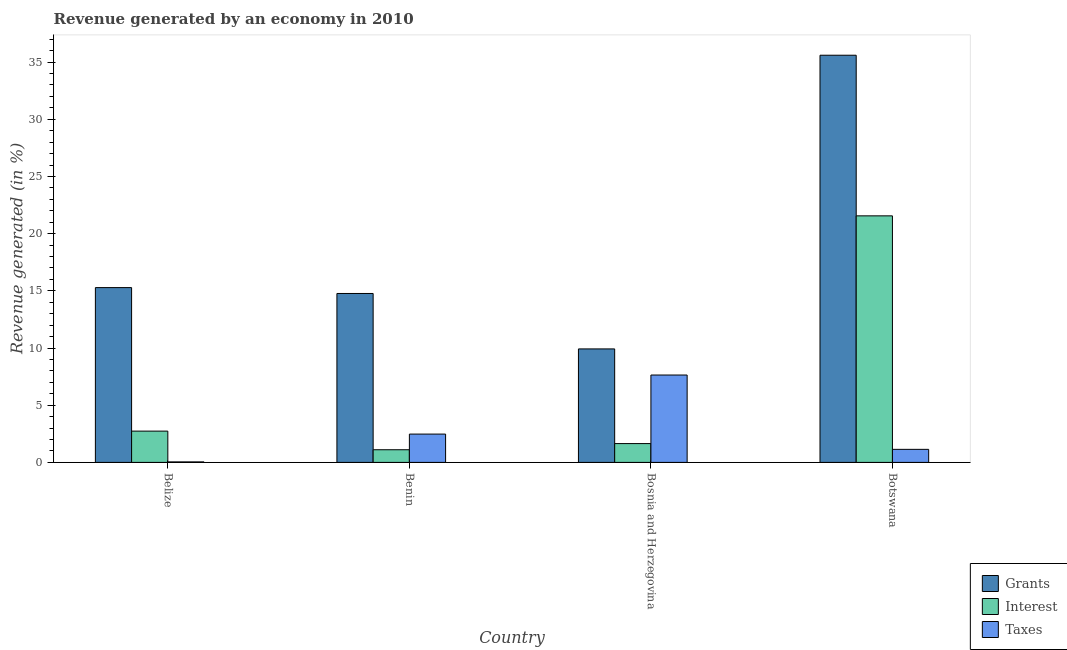Are the number of bars on each tick of the X-axis equal?
Make the answer very short. Yes. What is the label of the 2nd group of bars from the left?
Your answer should be compact. Benin. What is the percentage of revenue generated by interest in Bosnia and Herzegovina?
Keep it short and to the point. 1.64. Across all countries, what is the maximum percentage of revenue generated by taxes?
Ensure brevity in your answer.  7.64. Across all countries, what is the minimum percentage of revenue generated by taxes?
Give a very brief answer. 0.04. In which country was the percentage of revenue generated by interest maximum?
Provide a succinct answer. Botswana. In which country was the percentage of revenue generated by interest minimum?
Your answer should be compact. Benin. What is the total percentage of revenue generated by taxes in the graph?
Keep it short and to the point. 11.3. What is the difference between the percentage of revenue generated by grants in Benin and that in Botswana?
Your answer should be compact. -20.83. What is the difference between the percentage of revenue generated by grants in Benin and the percentage of revenue generated by taxes in Belize?
Make the answer very short. 14.73. What is the average percentage of revenue generated by interest per country?
Keep it short and to the point. 6.76. What is the difference between the percentage of revenue generated by taxes and percentage of revenue generated by interest in Botswana?
Give a very brief answer. -20.42. What is the ratio of the percentage of revenue generated by grants in Benin to that in Botswana?
Offer a very short reply. 0.41. What is the difference between the highest and the second highest percentage of revenue generated by interest?
Your answer should be compact. 18.82. What is the difference between the highest and the lowest percentage of revenue generated by interest?
Your answer should be compact. 20.45. In how many countries, is the percentage of revenue generated by grants greater than the average percentage of revenue generated by grants taken over all countries?
Ensure brevity in your answer.  1. What does the 2nd bar from the left in Belize represents?
Keep it short and to the point. Interest. What does the 3rd bar from the right in Bosnia and Herzegovina represents?
Provide a short and direct response. Grants. What is the difference between two consecutive major ticks on the Y-axis?
Provide a short and direct response. 5. Does the graph contain any zero values?
Give a very brief answer. No. Does the graph contain grids?
Keep it short and to the point. No. How many legend labels are there?
Your answer should be very brief. 3. What is the title of the graph?
Your response must be concise. Revenue generated by an economy in 2010. Does "Male employers" appear as one of the legend labels in the graph?
Provide a short and direct response. No. What is the label or title of the X-axis?
Your answer should be very brief. Country. What is the label or title of the Y-axis?
Ensure brevity in your answer.  Revenue generated (in %). What is the Revenue generated (in %) of Grants in Belize?
Make the answer very short. 15.28. What is the Revenue generated (in %) of Interest in Belize?
Ensure brevity in your answer.  2.74. What is the Revenue generated (in %) of Taxes in Belize?
Your answer should be compact. 0.04. What is the Revenue generated (in %) in Grants in Benin?
Your response must be concise. 14.77. What is the Revenue generated (in %) of Interest in Benin?
Provide a short and direct response. 1.11. What is the Revenue generated (in %) in Taxes in Benin?
Provide a succinct answer. 2.47. What is the Revenue generated (in %) in Grants in Bosnia and Herzegovina?
Your answer should be very brief. 9.92. What is the Revenue generated (in %) in Interest in Bosnia and Herzegovina?
Offer a terse response. 1.64. What is the Revenue generated (in %) of Taxes in Bosnia and Herzegovina?
Offer a very short reply. 7.64. What is the Revenue generated (in %) in Grants in Botswana?
Provide a short and direct response. 35.6. What is the Revenue generated (in %) in Interest in Botswana?
Offer a terse response. 21.56. What is the Revenue generated (in %) in Taxes in Botswana?
Offer a terse response. 1.14. Across all countries, what is the maximum Revenue generated (in %) of Grants?
Your answer should be compact. 35.6. Across all countries, what is the maximum Revenue generated (in %) of Interest?
Offer a terse response. 21.56. Across all countries, what is the maximum Revenue generated (in %) of Taxes?
Ensure brevity in your answer.  7.64. Across all countries, what is the minimum Revenue generated (in %) in Grants?
Your answer should be very brief. 9.92. Across all countries, what is the minimum Revenue generated (in %) of Interest?
Your response must be concise. 1.11. Across all countries, what is the minimum Revenue generated (in %) in Taxes?
Offer a terse response. 0.04. What is the total Revenue generated (in %) of Grants in the graph?
Make the answer very short. 75.57. What is the total Revenue generated (in %) of Interest in the graph?
Offer a terse response. 27.04. What is the total Revenue generated (in %) of Taxes in the graph?
Offer a terse response. 11.3. What is the difference between the Revenue generated (in %) of Grants in Belize and that in Benin?
Keep it short and to the point. 0.51. What is the difference between the Revenue generated (in %) in Interest in Belize and that in Benin?
Provide a succinct answer. 1.63. What is the difference between the Revenue generated (in %) in Taxes in Belize and that in Benin?
Your response must be concise. -2.43. What is the difference between the Revenue generated (in %) of Grants in Belize and that in Bosnia and Herzegovina?
Give a very brief answer. 5.36. What is the difference between the Revenue generated (in %) in Taxes in Belize and that in Bosnia and Herzegovina?
Offer a terse response. -7.6. What is the difference between the Revenue generated (in %) in Grants in Belize and that in Botswana?
Offer a very short reply. -20.32. What is the difference between the Revenue generated (in %) of Interest in Belize and that in Botswana?
Keep it short and to the point. -18.82. What is the difference between the Revenue generated (in %) in Taxes in Belize and that in Botswana?
Keep it short and to the point. -1.1. What is the difference between the Revenue generated (in %) of Grants in Benin and that in Bosnia and Herzegovina?
Ensure brevity in your answer.  4.85. What is the difference between the Revenue generated (in %) of Interest in Benin and that in Bosnia and Herzegovina?
Your answer should be compact. -0.54. What is the difference between the Revenue generated (in %) of Taxes in Benin and that in Bosnia and Herzegovina?
Provide a short and direct response. -5.16. What is the difference between the Revenue generated (in %) in Grants in Benin and that in Botswana?
Offer a very short reply. -20.83. What is the difference between the Revenue generated (in %) in Interest in Benin and that in Botswana?
Provide a succinct answer. -20.45. What is the difference between the Revenue generated (in %) of Taxes in Benin and that in Botswana?
Provide a succinct answer. 1.33. What is the difference between the Revenue generated (in %) of Grants in Bosnia and Herzegovina and that in Botswana?
Make the answer very short. -25.68. What is the difference between the Revenue generated (in %) of Interest in Bosnia and Herzegovina and that in Botswana?
Give a very brief answer. -19.91. What is the difference between the Revenue generated (in %) of Taxes in Bosnia and Herzegovina and that in Botswana?
Give a very brief answer. 6.5. What is the difference between the Revenue generated (in %) in Grants in Belize and the Revenue generated (in %) in Interest in Benin?
Your answer should be very brief. 14.18. What is the difference between the Revenue generated (in %) in Grants in Belize and the Revenue generated (in %) in Taxes in Benin?
Offer a terse response. 12.81. What is the difference between the Revenue generated (in %) of Interest in Belize and the Revenue generated (in %) of Taxes in Benin?
Make the answer very short. 0.26. What is the difference between the Revenue generated (in %) of Grants in Belize and the Revenue generated (in %) of Interest in Bosnia and Herzegovina?
Provide a succinct answer. 13.64. What is the difference between the Revenue generated (in %) in Grants in Belize and the Revenue generated (in %) in Taxes in Bosnia and Herzegovina?
Keep it short and to the point. 7.64. What is the difference between the Revenue generated (in %) in Interest in Belize and the Revenue generated (in %) in Taxes in Bosnia and Herzegovina?
Your response must be concise. -4.9. What is the difference between the Revenue generated (in %) in Grants in Belize and the Revenue generated (in %) in Interest in Botswana?
Your answer should be compact. -6.27. What is the difference between the Revenue generated (in %) of Grants in Belize and the Revenue generated (in %) of Taxes in Botswana?
Give a very brief answer. 14.14. What is the difference between the Revenue generated (in %) in Interest in Belize and the Revenue generated (in %) in Taxes in Botswana?
Offer a very short reply. 1.59. What is the difference between the Revenue generated (in %) in Grants in Benin and the Revenue generated (in %) in Interest in Bosnia and Herzegovina?
Your answer should be very brief. 13.12. What is the difference between the Revenue generated (in %) in Grants in Benin and the Revenue generated (in %) in Taxes in Bosnia and Herzegovina?
Provide a short and direct response. 7.13. What is the difference between the Revenue generated (in %) in Interest in Benin and the Revenue generated (in %) in Taxes in Bosnia and Herzegovina?
Provide a succinct answer. -6.53. What is the difference between the Revenue generated (in %) in Grants in Benin and the Revenue generated (in %) in Interest in Botswana?
Keep it short and to the point. -6.79. What is the difference between the Revenue generated (in %) in Grants in Benin and the Revenue generated (in %) in Taxes in Botswana?
Give a very brief answer. 13.63. What is the difference between the Revenue generated (in %) of Interest in Benin and the Revenue generated (in %) of Taxes in Botswana?
Your answer should be compact. -0.03. What is the difference between the Revenue generated (in %) in Grants in Bosnia and Herzegovina and the Revenue generated (in %) in Interest in Botswana?
Offer a very short reply. -11.63. What is the difference between the Revenue generated (in %) in Grants in Bosnia and Herzegovina and the Revenue generated (in %) in Taxes in Botswana?
Keep it short and to the point. 8.78. What is the difference between the Revenue generated (in %) in Interest in Bosnia and Herzegovina and the Revenue generated (in %) in Taxes in Botswana?
Give a very brief answer. 0.5. What is the average Revenue generated (in %) of Grants per country?
Make the answer very short. 18.89. What is the average Revenue generated (in %) in Interest per country?
Your answer should be compact. 6.76. What is the average Revenue generated (in %) in Taxes per country?
Your answer should be very brief. 2.82. What is the difference between the Revenue generated (in %) in Grants and Revenue generated (in %) in Interest in Belize?
Keep it short and to the point. 12.55. What is the difference between the Revenue generated (in %) in Grants and Revenue generated (in %) in Taxes in Belize?
Keep it short and to the point. 15.24. What is the difference between the Revenue generated (in %) in Interest and Revenue generated (in %) in Taxes in Belize?
Provide a succinct answer. 2.69. What is the difference between the Revenue generated (in %) of Grants and Revenue generated (in %) of Interest in Benin?
Provide a succinct answer. 13.66. What is the difference between the Revenue generated (in %) of Grants and Revenue generated (in %) of Taxes in Benin?
Keep it short and to the point. 12.29. What is the difference between the Revenue generated (in %) in Interest and Revenue generated (in %) in Taxes in Benin?
Your answer should be very brief. -1.37. What is the difference between the Revenue generated (in %) in Grants and Revenue generated (in %) in Interest in Bosnia and Herzegovina?
Provide a succinct answer. 8.28. What is the difference between the Revenue generated (in %) in Grants and Revenue generated (in %) in Taxes in Bosnia and Herzegovina?
Your answer should be compact. 2.28. What is the difference between the Revenue generated (in %) in Interest and Revenue generated (in %) in Taxes in Bosnia and Herzegovina?
Offer a very short reply. -6. What is the difference between the Revenue generated (in %) in Grants and Revenue generated (in %) in Interest in Botswana?
Your answer should be very brief. 14.04. What is the difference between the Revenue generated (in %) of Grants and Revenue generated (in %) of Taxes in Botswana?
Ensure brevity in your answer.  34.46. What is the difference between the Revenue generated (in %) in Interest and Revenue generated (in %) in Taxes in Botswana?
Your answer should be compact. 20.42. What is the ratio of the Revenue generated (in %) in Grants in Belize to that in Benin?
Offer a very short reply. 1.03. What is the ratio of the Revenue generated (in %) in Interest in Belize to that in Benin?
Make the answer very short. 2.47. What is the ratio of the Revenue generated (in %) of Taxes in Belize to that in Benin?
Make the answer very short. 0.02. What is the ratio of the Revenue generated (in %) in Grants in Belize to that in Bosnia and Herzegovina?
Provide a succinct answer. 1.54. What is the ratio of the Revenue generated (in %) of Interest in Belize to that in Bosnia and Herzegovina?
Keep it short and to the point. 1.66. What is the ratio of the Revenue generated (in %) of Taxes in Belize to that in Bosnia and Herzegovina?
Your answer should be very brief. 0.01. What is the ratio of the Revenue generated (in %) of Grants in Belize to that in Botswana?
Your answer should be compact. 0.43. What is the ratio of the Revenue generated (in %) in Interest in Belize to that in Botswana?
Your response must be concise. 0.13. What is the ratio of the Revenue generated (in %) of Taxes in Belize to that in Botswana?
Your answer should be compact. 0.04. What is the ratio of the Revenue generated (in %) in Grants in Benin to that in Bosnia and Herzegovina?
Offer a terse response. 1.49. What is the ratio of the Revenue generated (in %) in Interest in Benin to that in Bosnia and Herzegovina?
Your response must be concise. 0.67. What is the ratio of the Revenue generated (in %) in Taxes in Benin to that in Bosnia and Herzegovina?
Keep it short and to the point. 0.32. What is the ratio of the Revenue generated (in %) in Grants in Benin to that in Botswana?
Your response must be concise. 0.41. What is the ratio of the Revenue generated (in %) in Interest in Benin to that in Botswana?
Offer a very short reply. 0.05. What is the ratio of the Revenue generated (in %) of Taxes in Benin to that in Botswana?
Your answer should be compact. 2.17. What is the ratio of the Revenue generated (in %) in Grants in Bosnia and Herzegovina to that in Botswana?
Your answer should be compact. 0.28. What is the ratio of the Revenue generated (in %) of Interest in Bosnia and Herzegovina to that in Botswana?
Offer a terse response. 0.08. What is the ratio of the Revenue generated (in %) of Taxes in Bosnia and Herzegovina to that in Botswana?
Offer a terse response. 6.7. What is the difference between the highest and the second highest Revenue generated (in %) in Grants?
Give a very brief answer. 20.32. What is the difference between the highest and the second highest Revenue generated (in %) of Interest?
Provide a short and direct response. 18.82. What is the difference between the highest and the second highest Revenue generated (in %) in Taxes?
Offer a very short reply. 5.16. What is the difference between the highest and the lowest Revenue generated (in %) of Grants?
Your answer should be very brief. 25.68. What is the difference between the highest and the lowest Revenue generated (in %) of Interest?
Keep it short and to the point. 20.45. What is the difference between the highest and the lowest Revenue generated (in %) in Taxes?
Offer a very short reply. 7.6. 